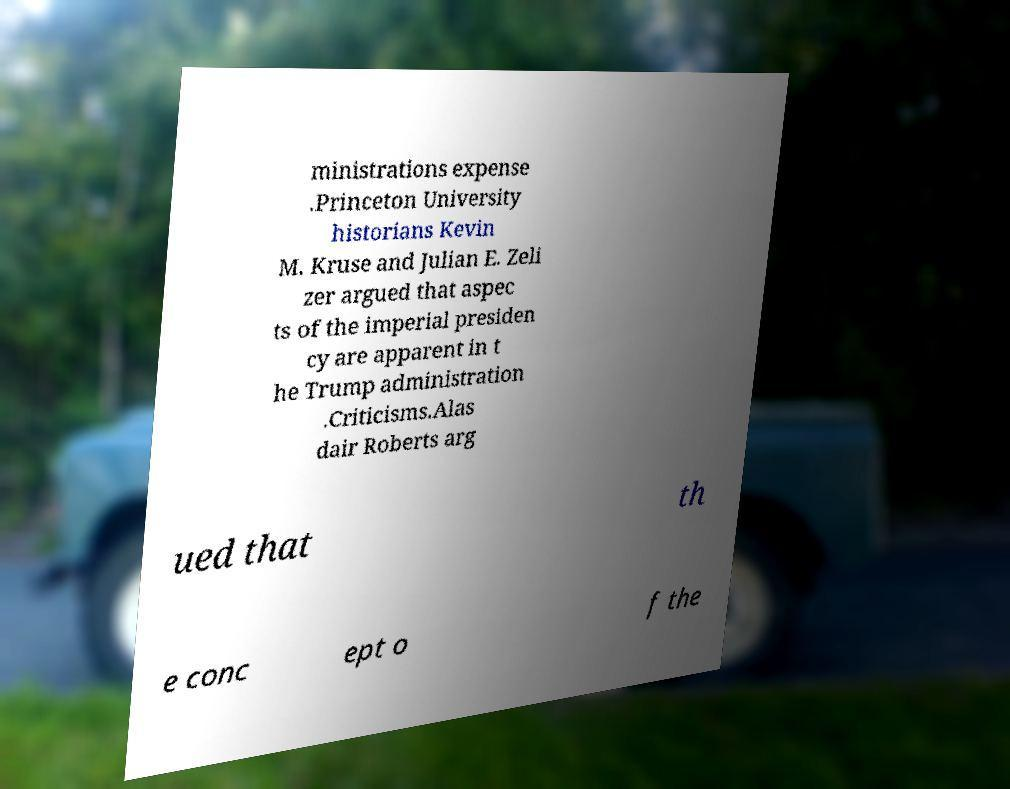Could you assist in decoding the text presented in this image and type it out clearly? ministrations expense .Princeton University historians Kevin M. Kruse and Julian E. Zeli zer argued that aspec ts of the imperial presiden cy are apparent in t he Trump administration .Criticisms.Alas dair Roberts arg ued that th e conc ept o f the 